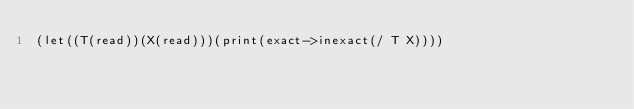Convert code to text. <code><loc_0><loc_0><loc_500><loc_500><_Scheme_>(let((T(read))(X(read)))(print(exact->inexact(/ T X))))</code> 